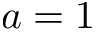Convert formula to latex. <formula><loc_0><loc_0><loc_500><loc_500>a = 1</formula> 